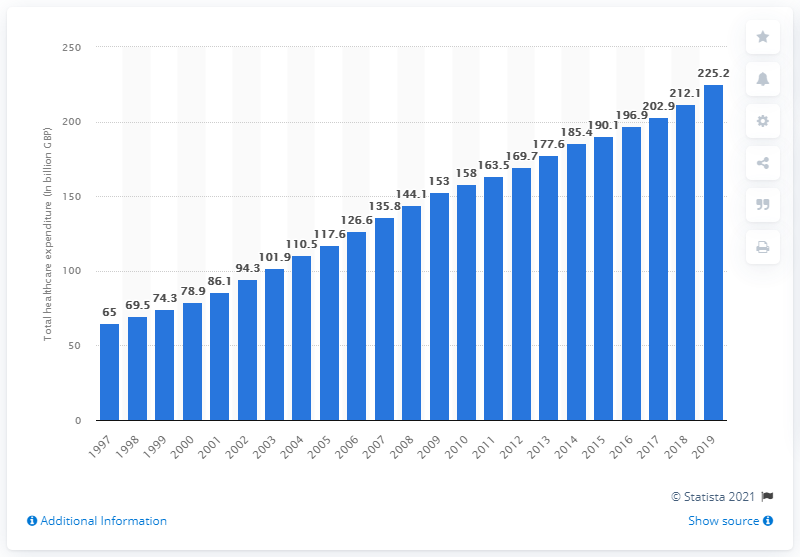Give some essential details in this illustration. In 2019, the amount of money spent on healthcare in the United Kingdom was 225.2 billion pounds. In 1997, the amount of money spent on healthcare in the UK was 65.. 